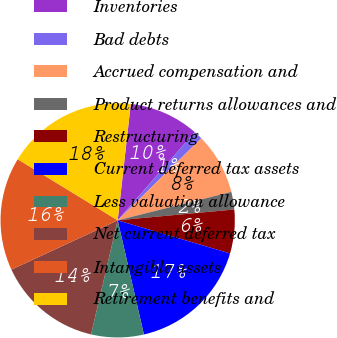Convert chart to OTSL. <chart><loc_0><loc_0><loc_500><loc_500><pie_chart><fcel>Inventories<fcel>Bad debts<fcel>Accrued compensation and<fcel>Product returns allowances and<fcel>Restructuring<fcel>Current deferred tax assets<fcel>Less valuation allowance<fcel>Net current deferred tax<fcel>Intangible assets<fcel>Retirement benefits and<nl><fcel>9.64%<fcel>1.23%<fcel>8.44%<fcel>2.43%<fcel>6.04%<fcel>16.84%<fcel>7.24%<fcel>14.44%<fcel>15.64%<fcel>18.05%<nl></chart> 